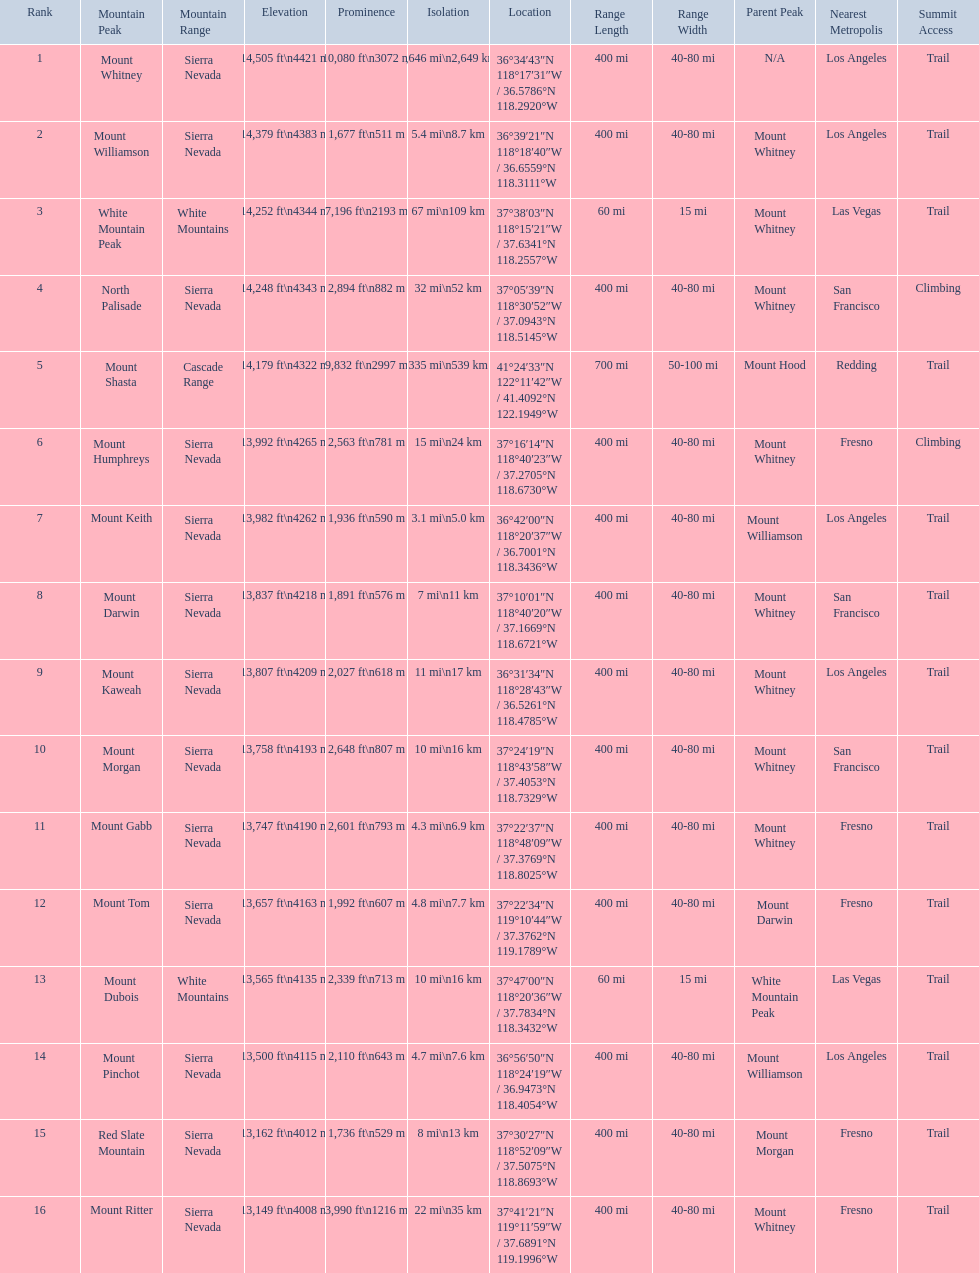What are the heights of the californian mountain peaks? 14,505 ft\n4421 m, 14,379 ft\n4383 m, 14,252 ft\n4344 m, 14,248 ft\n4343 m, 14,179 ft\n4322 m, 13,992 ft\n4265 m, 13,982 ft\n4262 m, 13,837 ft\n4218 m, 13,807 ft\n4209 m, 13,758 ft\n4193 m, 13,747 ft\n4190 m, 13,657 ft\n4163 m, 13,565 ft\n4135 m, 13,500 ft\n4115 m, 13,162 ft\n4012 m, 13,149 ft\n4008 m. What elevation is 13,149 ft or less? 13,149 ft\n4008 m. What mountain peak is at this elevation? Mount Ritter. 